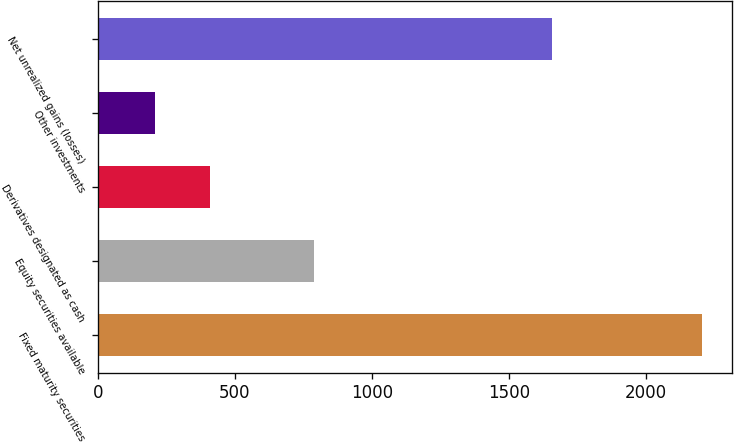<chart> <loc_0><loc_0><loc_500><loc_500><bar_chart><fcel>Fixed maturity securities<fcel>Equity securities available<fcel>Derivatives designated as cash<fcel>Other investments<fcel>Net unrealized gains (losses)<nl><fcel>2203<fcel>789<fcel>409.3<fcel>210<fcel>1656<nl></chart> 